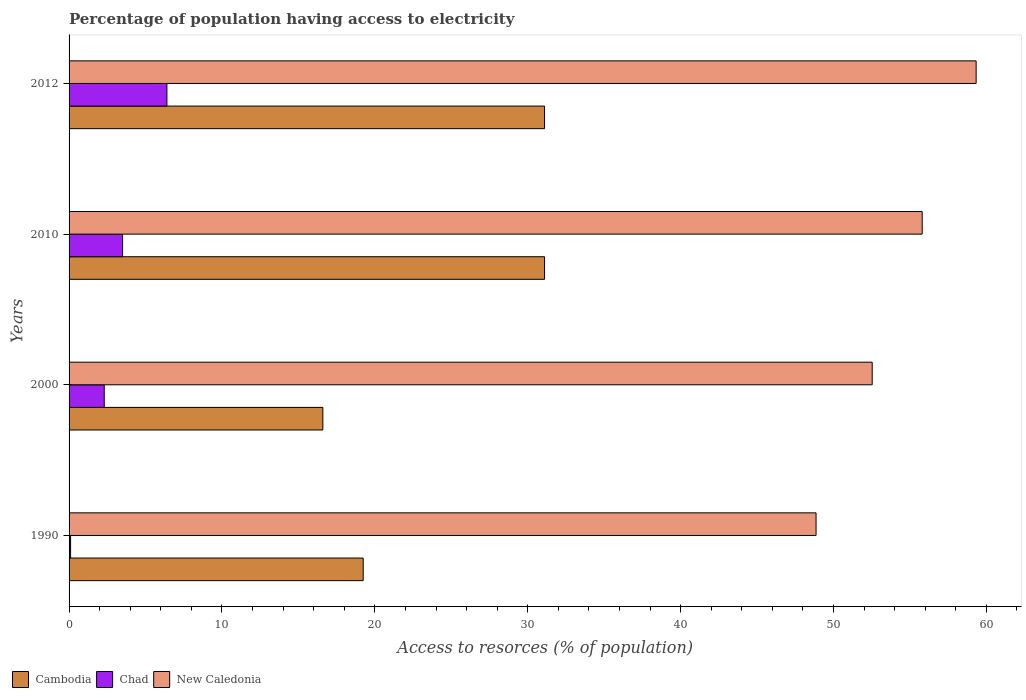How many different coloured bars are there?
Give a very brief answer. 3. How many groups of bars are there?
Give a very brief answer. 4. Are the number of bars per tick equal to the number of legend labels?
Keep it short and to the point. Yes. Are the number of bars on each tick of the Y-axis equal?
Make the answer very short. Yes. How many bars are there on the 3rd tick from the top?
Give a very brief answer. 3. How many bars are there on the 4th tick from the bottom?
Ensure brevity in your answer.  3. In how many cases, is the number of bars for a given year not equal to the number of legend labels?
Provide a succinct answer. 0. What is the percentage of population having access to electricity in New Caledonia in 2010?
Your response must be concise. 55.8. Across all years, what is the maximum percentage of population having access to electricity in Chad?
Your answer should be very brief. 6.4. Across all years, what is the minimum percentage of population having access to electricity in New Caledonia?
Provide a short and direct response. 48.86. In which year was the percentage of population having access to electricity in Chad minimum?
Your answer should be very brief. 1990. What is the total percentage of population having access to electricity in Chad in the graph?
Offer a terse response. 12.3. What is the difference between the percentage of population having access to electricity in New Caledonia in 2000 and that in 2012?
Ensure brevity in your answer.  -6.8. What is the difference between the percentage of population having access to electricity in Cambodia in 2000 and the percentage of population having access to electricity in New Caledonia in 2012?
Keep it short and to the point. -42.73. What is the average percentage of population having access to electricity in Cambodia per year?
Provide a short and direct response. 24.51. In the year 2010, what is the difference between the percentage of population having access to electricity in New Caledonia and percentage of population having access to electricity in Cambodia?
Offer a very short reply. 24.7. What is the ratio of the percentage of population having access to electricity in New Caledonia in 2000 to that in 2010?
Your answer should be very brief. 0.94. What is the difference between the highest and the second highest percentage of population having access to electricity in Chad?
Offer a terse response. 2.9. What is the difference between the highest and the lowest percentage of population having access to electricity in Chad?
Your answer should be compact. 6.3. Is the sum of the percentage of population having access to electricity in Chad in 2000 and 2012 greater than the maximum percentage of population having access to electricity in Cambodia across all years?
Give a very brief answer. No. What does the 1st bar from the top in 1990 represents?
Give a very brief answer. New Caledonia. What does the 3rd bar from the bottom in 2000 represents?
Your answer should be very brief. New Caledonia. Is it the case that in every year, the sum of the percentage of population having access to electricity in New Caledonia and percentage of population having access to electricity in Cambodia is greater than the percentage of population having access to electricity in Chad?
Provide a succinct answer. Yes. How many bars are there?
Your response must be concise. 12. Are the values on the major ticks of X-axis written in scientific E-notation?
Provide a short and direct response. No. Does the graph contain any zero values?
Your answer should be compact. No. Does the graph contain grids?
Ensure brevity in your answer.  No. Where does the legend appear in the graph?
Keep it short and to the point. Bottom left. What is the title of the graph?
Ensure brevity in your answer.  Percentage of population having access to electricity. What is the label or title of the X-axis?
Make the answer very short. Access to resorces (% of population). What is the label or title of the Y-axis?
Provide a succinct answer. Years. What is the Access to resorces (% of population) in Cambodia in 1990?
Provide a succinct answer. 19.24. What is the Access to resorces (% of population) of Chad in 1990?
Your response must be concise. 0.1. What is the Access to resorces (% of population) of New Caledonia in 1990?
Your answer should be very brief. 48.86. What is the Access to resorces (% of population) in New Caledonia in 2000?
Keep it short and to the point. 52.53. What is the Access to resorces (% of population) of Cambodia in 2010?
Make the answer very short. 31.1. What is the Access to resorces (% of population) of New Caledonia in 2010?
Your answer should be very brief. 55.8. What is the Access to resorces (% of population) in Cambodia in 2012?
Provide a succinct answer. 31.1. What is the Access to resorces (% of population) in Chad in 2012?
Provide a short and direct response. 6.4. What is the Access to resorces (% of population) in New Caledonia in 2012?
Offer a very short reply. 59.33. Across all years, what is the maximum Access to resorces (% of population) of Cambodia?
Your answer should be compact. 31.1. Across all years, what is the maximum Access to resorces (% of population) of Chad?
Your response must be concise. 6.4. Across all years, what is the maximum Access to resorces (% of population) in New Caledonia?
Keep it short and to the point. 59.33. Across all years, what is the minimum Access to resorces (% of population) of Cambodia?
Provide a short and direct response. 16.6. Across all years, what is the minimum Access to resorces (% of population) of Chad?
Ensure brevity in your answer.  0.1. Across all years, what is the minimum Access to resorces (% of population) in New Caledonia?
Give a very brief answer. 48.86. What is the total Access to resorces (% of population) of Cambodia in the graph?
Make the answer very short. 98.04. What is the total Access to resorces (% of population) of Chad in the graph?
Offer a very short reply. 12.3. What is the total Access to resorces (% of population) in New Caledonia in the graph?
Keep it short and to the point. 216.52. What is the difference between the Access to resorces (% of population) in Cambodia in 1990 and that in 2000?
Ensure brevity in your answer.  2.64. What is the difference between the Access to resorces (% of population) of Chad in 1990 and that in 2000?
Provide a short and direct response. -2.2. What is the difference between the Access to resorces (% of population) of New Caledonia in 1990 and that in 2000?
Offer a terse response. -3.67. What is the difference between the Access to resorces (% of population) of Cambodia in 1990 and that in 2010?
Your answer should be very brief. -11.86. What is the difference between the Access to resorces (% of population) in New Caledonia in 1990 and that in 2010?
Give a very brief answer. -6.94. What is the difference between the Access to resorces (% of population) in Cambodia in 1990 and that in 2012?
Give a very brief answer. -11.86. What is the difference between the Access to resorces (% of population) in Chad in 1990 and that in 2012?
Make the answer very short. -6.3. What is the difference between the Access to resorces (% of population) in New Caledonia in 1990 and that in 2012?
Offer a very short reply. -10.47. What is the difference between the Access to resorces (% of population) of Cambodia in 2000 and that in 2010?
Ensure brevity in your answer.  -14.5. What is the difference between the Access to resorces (% of population) of New Caledonia in 2000 and that in 2010?
Keep it short and to the point. -3.27. What is the difference between the Access to resorces (% of population) of Chad in 2000 and that in 2012?
Keep it short and to the point. -4.1. What is the difference between the Access to resorces (% of population) in New Caledonia in 2000 and that in 2012?
Keep it short and to the point. -6.8. What is the difference between the Access to resorces (% of population) of Cambodia in 2010 and that in 2012?
Give a very brief answer. 0. What is the difference between the Access to resorces (% of population) of New Caledonia in 2010 and that in 2012?
Ensure brevity in your answer.  -3.53. What is the difference between the Access to resorces (% of population) in Cambodia in 1990 and the Access to resorces (% of population) in Chad in 2000?
Make the answer very short. 16.94. What is the difference between the Access to resorces (% of population) in Cambodia in 1990 and the Access to resorces (% of population) in New Caledonia in 2000?
Keep it short and to the point. -33.29. What is the difference between the Access to resorces (% of population) of Chad in 1990 and the Access to resorces (% of population) of New Caledonia in 2000?
Your response must be concise. -52.43. What is the difference between the Access to resorces (% of population) in Cambodia in 1990 and the Access to resorces (% of population) in Chad in 2010?
Make the answer very short. 15.74. What is the difference between the Access to resorces (% of population) of Cambodia in 1990 and the Access to resorces (% of population) of New Caledonia in 2010?
Give a very brief answer. -36.56. What is the difference between the Access to resorces (% of population) of Chad in 1990 and the Access to resorces (% of population) of New Caledonia in 2010?
Offer a terse response. -55.7. What is the difference between the Access to resorces (% of population) in Cambodia in 1990 and the Access to resorces (% of population) in Chad in 2012?
Give a very brief answer. 12.84. What is the difference between the Access to resorces (% of population) in Cambodia in 1990 and the Access to resorces (% of population) in New Caledonia in 2012?
Offer a very short reply. -40.09. What is the difference between the Access to resorces (% of population) in Chad in 1990 and the Access to resorces (% of population) in New Caledonia in 2012?
Your response must be concise. -59.23. What is the difference between the Access to resorces (% of population) in Cambodia in 2000 and the Access to resorces (% of population) in Chad in 2010?
Your answer should be compact. 13.1. What is the difference between the Access to resorces (% of population) of Cambodia in 2000 and the Access to resorces (% of population) of New Caledonia in 2010?
Provide a short and direct response. -39.2. What is the difference between the Access to resorces (% of population) of Chad in 2000 and the Access to resorces (% of population) of New Caledonia in 2010?
Ensure brevity in your answer.  -53.5. What is the difference between the Access to resorces (% of population) in Cambodia in 2000 and the Access to resorces (% of population) in Chad in 2012?
Offer a very short reply. 10.2. What is the difference between the Access to resorces (% of population) of Cambodia in 2000 and the Access to resorces (% of population) of New Caledonia in 2012?
Give a very brief answer. -42.73. What is the difference between the Access to resorces (% of population) in Chad in 2000 and the Access to resorces (% of population) in New Caledonia in 2012?
Provide a short and direct response. -57.03. What is the difference between the Access to resorces (% of population) of Cambodia in 2010 and the Access to resorces (% of population) of Chad in 2012?
Keep it short and to the point. 24.7. What is the difference between the Access to resorces (% of population) of Cambodia in 2010 and the Access to resorces (% of population) of New Caledonia in 2012?
Give a very brief answer. -28.23. What is the difference between the Access to resorces (% of population) of Chad in 2010 and the Access to resorces (% of population) of New Caledonia in 2012?
Offer a terse response. -55.83. What is the average Access to resorces (% of population) of Cambodia per year?
Keep it short and to the point. 24.51. What is the average Access to resorces (% of population) in Chad per year?
Your answer should be compact. 3.08. What is the average Access to resorces (% of population) in New Caledonia per year?
Provide a succinct answer. 54.13. In the year 1990, what is the difference between the Access to resorces (% of population) of Cambodia and Access to resorces (% of population) of Chad?
Your response must be concise. 19.14. In the year 1990, what is the difference between the Access to resorces (% of population) of Cambodia and Access to resorces (% of population) of New Caledonia?
Provide a succinct answer. -29.62. In the year 1990, what is the difference between the Access to resorces (% of population) in Chad and Access to resorces (% of population) in New Caledonia?
Your answer should be compact. -48.76. In the year 2000, what is the difference between the Access to resorces (% of population) of Cambodia and Access to resorces (% of population) of Chad?
Ensure brevity in your answer.  14.3. In the year 2000, what is the difference between the Access to resorces (% of population) of Cambodia and Access to resorces (% of population) of New Caledonia?
Offer a terse response. -35.93. In the year 2000, what is the difference between the Access to resorces (% of population) of Chad and Access to resorces (% of population) of New Caledonia?
Keep it short and to the point. -50.23. In the year 2010, what is the difference between the Access to resorces (% of population) of Cambodia and Access to resorces (% of population) of Chad?
Your answer should be very brief. 27.6. In the year 2010, what is the difference between the Access to resorces (% of population) of Cambodia and Access to resorces (% of population) of New Caledonia?
Provide a short and direct response. -24.7. In the year 2010, what is the difference between the Access to resorces (% of population) of Chad and Access to resorces (% of population) of New Caledonia?
Provide a succinct answer. -52.3. In the year 2012, what is the difference between the Access to resorces (% of population) of Cambodia and Access to resorces (% of population) of Chad?
Offer a very short reply. 24.7. In the year 2012, what is the difference between the Access to resorces (% of population) of Cambodia and Access to resorces (% of population) of New Caledonia?
Offer a very short reply. -28.23. In the year 2012, what is the difference between the Access to resorces (% of population) in Chad and Access to resorces (% of population) in New Caledonia?
Offer a terse response. -52.93. What is the ratio of the Access to resorces (% of population) in Cambodia in 1990 to that in 2000?
Make the answer very short. 1.16. What is the ratio of the Access to resorces (% of population) of Chad in 1990 to that in 2000?
Give a very brief answer. 0.04. What is the ratio of the Access to resorces (% of population) of New Caledonia in 1990 to that in 2000?
Make the answer very short. 0.93. What is the ratio of the Access to resorces (% of population) in Cambodia in 1990 to that in 2010?
Your response must be concise. 0.62. What is the ratio of the Access to resorces (% of population) in Chad in 1990 to that in 2010?
Give a very brief answer. 0.03. What is the ratio of the Access to resorces (% of population) in New Caledonia in 1990 to that in 2010?
Give a very brief answer. 0.88. What is the ratio of the Access to resorces (% of population) in Cambodia in 1990 to that in 2012?
Give a very brief answer. 0.62. What is the ratio of the Access to resorces (% of population) of Chad in 1990 to that in 2012?
Make the answer very short. 0.02. What is the ratio of the Access to resorces (% of population) in New Caledonia in 1990 to that in 2012?
Provide a short and direct response. 0.82. What is the ratio of the Access to resorces (% of population) in Cambodia in 2000 to that in 2010?
Keep it short and to the point. 0.53. What is the ratio of the Access to resorces (% of population) of Chad in 2000 to that in 2010?
Offer a terse response. 0.66. What is the ratio of the Access to resorces (% of population) of New Caledonia in 2000 to that in 2010?
Keep it short and to the point. 0.94. What is the ratio of the Access to resorces (% of population) in Cambodia in 2000 to that in 2012?
Offer a terse response. 0.53. What is the ratio of the Access to resorces (% of population) in Chad in 2000 to that in 2012?
Your response must be concise. 0.36. What is the ratio of the Access to resorces (% of population) of New Caledonia in 2000 to that in 2012?
Make the answer very short. 0.89. What is the ratio of the Access to resorces (% of population) of Chad in 2010 to that in 2012?
Provide a succinct answer. 0.55. What is the ratio of the Access to resorces (% of population) in New Caledonia in 2010 to that in 2012?
Offer a terse response. 0.94. What is the difference between the highest and the second highest Access to resorces (% of population) of Chad?
Provide a short and direct response. 2.9. What is the difference between the highest and the second highest Access to resorces (% of population) in New Caledonia?
Provide a succinct answer. 3.53. What is the difference between the highest and the lowest Access to resorces (% of population) in New Caledonia?
Your answer should be very brief. 10.47. 